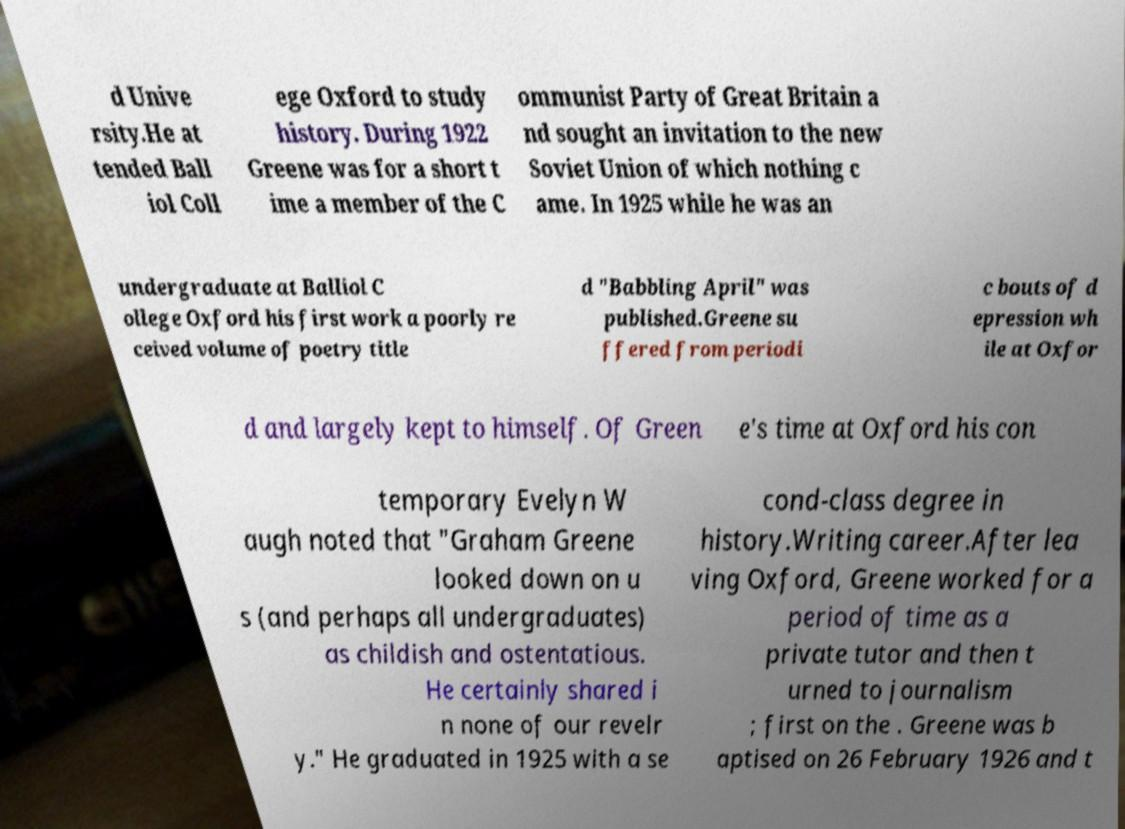Please identify and transcribe the text found in this image. d Unive rsity.He at tended Ball iol Coll ege Oxford to study history. During 1922 Greene was for a short t ime a member of the C ommunist Party of Great Britain a nd sought an invitation to the new Soviet Union of which nothing c ame. In 1925 while he was an undergraduate at Balliol C ollege Oxford his first work a poorly re ceived volume of poetry title d "Babbling April" was published.Greene su ffered from periodi c bouts of d epression wh ile at Oxfor d and largely kept to himself. Of Green e's time at Oxford his con temporary Evelyn W augh noted that "Graham Greene looked down on u s (and perhaps all undergraduates) as childish and ostentatious. He certainly shared i n none of our revelr y." He graduated in 1925 with a se cond-class degree in history.Writing career.After lea ving Oxford, Greene worked for a period of time as a private tutor and then t urned to journalism ; first on the . Greene was b aptised on 26 February 1926 and t 